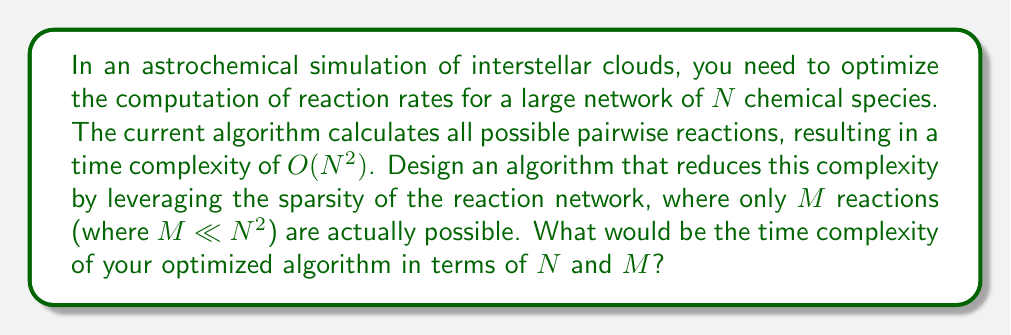Teach me how to tackle this problem. To optimize the computational efficiency of large-scale astrochemical simulations, we can follow these steps:

1. Recognize that the current algorithm, which computes all possible pairwise reactions, has a time complexity of $O(N^2)$ for $N$ chemical species.

2. Observe that in reality, only $M$ reactions are actually possible, where $M \ll N^2$. This indicates that the reaction network is sparse.

3. Instead of computing all possible pairwise reactions, we can use a sparse matrix representation to store only the valid reactions.

4. Implement a hash table or dictionary data structure where:
   - Keys are pairs of reactant species $(i, j)$
   - Values are the corresponding reaction rates $k_{ij}$

5. Populate this data structure with only the $M$ valid reactions.

6. When computing reaction rates, instead of iterating over all $N^2$ possibilities, we only need to iterate over the $M$ entries in our hash table.

7. Accessing elements in a hash table has an average time complexity of $O(1)$.

8. Therefore, the overall time complexity of our optimized algorithm would be $O(M)$, as we only need to perform computations for the $M$ valid reactions.

This approach significantly reduces the time complexity from $O(N^2)$ to $O(M)$, where $M \ll N^2$, resulting in a much more efficient algorithm for large-scale astrochemical simulations.
Answer: $O(M)$ 